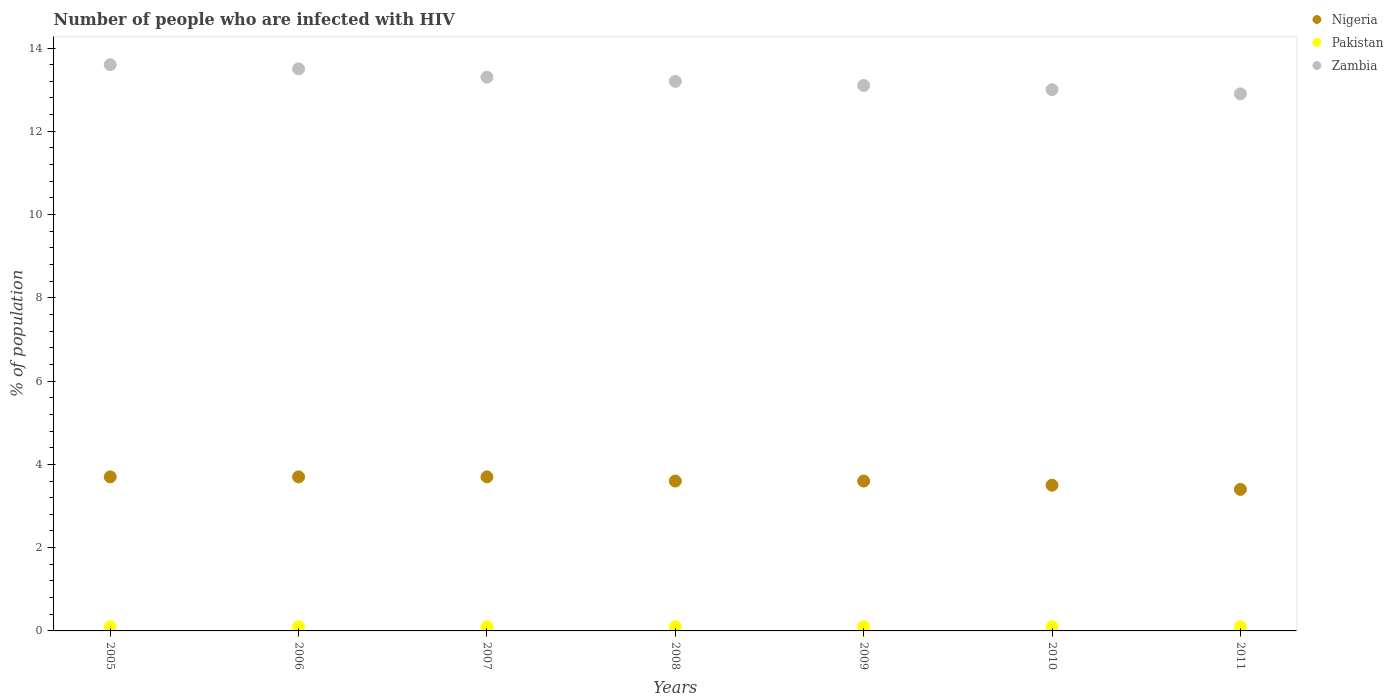Is the number of dotlines equal to the number of legend labels?
Ensure brevity in your answer.  Yes. In which year was the percentage of HIV infected population in in Pakistan maximum?
Provide a succinct answer. 2005. In which year was the percentage of HIV infected population in in Zambia minimum?
Offer a very short reply. 2011. What is the total percentage of HIV infected population in in Nigeria in the graph?
Offer a terse response. 25.2. What is the difference between the percentage of HIV infected population in in Zambia in 2009 and that in 2011?
Your response must be concise. 0.2. What is the difference between the percentage of HIV infected population in in Pakistan in 2006 and the percentage of HIV infected population in in Zambia in 2005?
Make the answer very short. -13.5. What is the average percentage of HIV infected population in in Zambia per year?
Your answer should be very brief. 13.23. In how many years, is the percentage of HIV infected population in in Nigeria greater than 8.8 %?
Your answer should be very brief. 0. What is the ratio of the percentage of HIV infected population in in Nigeria in 2006 to that in 2009?
Keep it short and to the point. 1.03. What is the difference between the highest and the lowest percentage of HIV infected population in in Zambia?
Your answer should be very brief. 0.7. Does the percentage of HIV infected population in in Zambia monotonically increase over the years?
Your answer should be compact. No. Is the percentage of HIV infected population in in Nigeria strictly greater than the percentage of HIV infected population in in Zambia over the years?
Ensure brevity in your answer.  No. Is the percentage of HIV infected population in in Zambia strictly less than the percentage of HIV infected population in in Nigeria over the years?
Offer a terse response. No. How many years are there in the graph?
Keep it short and to the point. 7. What is the difference between two consecutive major ticks on the Y-axis?
Your answer should be very brief. 2. Does the graph contain any zero values?
Provide a short and direct response. No. Does the graph contain grids?
Make the answer very short. No. Where does the legend appear in the graph?
Ensure brevity in your answer.  Top right. How are the legend labels stacked?
Keep it short and to the point. Vertical. What is the title of the graph?
Offer a very short reply. Number of people who are infected with HIV. Does "Cayman Islands" appear as one of the legend labels in the graph?
Provide a succinct answer. No. What is the label or title of the Y-axis?
Your answer should be very brief. % of population. What is the % of population of Zambia in 2005?
Make the answer very short. 13.6. What is the % of population in Nigeria in 2006?
Offer a very short reply. 3.7. What is the % of population in Pakistan in 2006?
Your answer should be compact. 0.1. What is the % of population of Nigeria in 2007?
Your answer should be compact. 3.7. What is the % of population in Pakistan in 2007?
Give a very brief answer. 0.1. What is the % of population of Zambia in 2007?
Your answer should be compact. 13.3. What is the % of population in Zambia in 2008?
Ensure brevity in your answer.  13.2. What is the % of population in Nigeria in 2009?
Provide a short and direct response. 3.6. What is the % of population in Pakistan in 2009?
Keep it short and to the point. 0.1. What is the % of population in Zambia in 2009?
Give a very brief answer. 13.1. What is the % of population of Pakistan in 2010?
Make the answer very short. 0.1. What is the % of population of Nigeria in 2011?
Make the answer very short. 3.4. What is the % of population of Pakistan in 2011?
Your answer should be compact. 0.1. What is the % of population of Zambia in 2011?
Provide a succinct answer. 12.9. Across all years, what is the maximum % of population of Nigeria?
Keep it short and to the point. 3.7. Across all years, what is the maximum % of population in Pakistan?
Give a very brief answer. 0.1. Across all years, what is the minimum % of population in Nigeria?
Your response must be concise. 3.4. What is the total % of population of Nigeria in the graph?
Ensure brevity in your answer.  25.2. What is the total % of population of Pakistan in the graph?
Ensure brevity in your answer.  0.7. What is the total % of population in Zambia in the graph?
Your answer should be very brief. 92.6. What is the difference between the % of population of Pakistan in 2005 and that in 2006?
Offer a very short reply. 0. What is the difference between the % of population of Zambia in 2005 and that in 2006?
Your answer should be compact. 0.1. What is the difference between the % of population in Zambia in 2005 and that in 2008?
Your answer should be compact. 0.4. What is the difference between the % of population of Nigeria in 2005 and that in 2009?
Offer a very short reply. 0.1. What is the difference between the % of population in Nigeria in 2005 and that in 2010?
Give a very brief answer. 0.2. What is the difference between the % of population in Pakistan in 2005 and that in 2010?
Give a very brief answer. 0. What is the difference between the % of population in Zambia in 2005 and that in 2010?
Your answer should be very brief. 0.6. What is the difference between the % of population in Nigeria in 2005 and that in 2011?
Your response must be concise. 0.3. What is the difference between the % of population in Zambia in 2005 and that in 2011?
Offer a very short reply. 0.7. What is the difference between the % of population in Pakistan in 2006 and that in 2007?
Offer a terse response. 0. What is the difference between the % of population of Zambia in 2006 and that in 2007?
Provide a succinct answer. 0.2. What is the difference between the % of population of Nigeria in 2006 and that in 2008?
Give a very brief answer. 0.1. What is the difference between the % of population in Zambia in 2006 and that in 2008?
Your answer should be compact. 0.3. What is the difference between the % of population of Nigeria in 2006 and that in 2009?
Make the answer very short. 0.1. What is the difference between the % of population of Zambia in 2006 and that in 2009?
Your answer should be very brief. 0.4. What is the difference between the % of population in Pakistan in 2006 and that in 2011?
Offer a terse response. 0. What is the difference between the % of population of Pakistan in 2007 and that in 2008?
Provide a short and direct response. 0. What is the difference between the % of population of Zambia in 2007 and that in 2008?
Keep it short and to the point. 0.1. What is the difference between the % of population of Nigeria in 2007 and that in 2009?
Ensure brevity in your answer.  0.1. What is the difference between the % of population in Nigeria in 2007 and that in 2010?
Your answer should be very brief. 0.2. What is the difference between the % of population of Zambia in 2007 and that in 2011?
Offer a terse response. 0.4. What is the difference between the % of population in Nigeria in 2008 and that in 2009?
Offer a terse response. 0. What is the difference between the % of population of Zambia in 2008 and that in 2009?
Your answer should be compact. 0.1. What is the difference between the % of population in Pakistan in 2008 and that in 2010?
Provide a short and direct response. 0. What is the difference between the % of population of Nigeria in 2009 and that in 2010?
Keep it short and to the point. 0.1. What is the difference between the % of population in Pakistan in 2009 and that in 2010?
Your answer should be compact. 0. What is the difference between the % of population of Nigeria in 2009 and that in 2011?
Give a very brief answer. 0.2. What is the difference between the % of population in Pakistan in 2009 and that in 2011?
Your response must be concise. 0. What is the difference between the % of population in Pakistan in 2010 and that in 2011?
Provide a succinct answer. 0. What is the difference between the % of population in Pakistan in 2005 and the % of population in Zambia in 2006?
Your answer should be compact. -13.4. What is the difference between the % of population in Nigeria in 2005 and the % of population in Pakistan in 2007?
Offer a very short reply. 3.6. What is the difference between the % of population of Nigeria in 2005 and the % of population of Zambia in 2007?
Your response must be concise. -9.6. What is the difference between the % of population of Nigeria in 2005 and the % of population of Zambia in 2008?
Offer a terse response. -9.5. What is the difference between the % of population in Nigeria in 2005 and the % of population in Pakistan in 2010?
Provide a succinct answer. 3.6. What is the difference between the % of population in Nigeria in 2005 and the % of population in Zambia in 2010?
Provide a succinct answer. -9.3. What is the difference between the % of population of Nigeria in 2006 and the % of population of Pakistan in 2007?
Your answer should be very brief. 3.6. What is the difference between the % of population of Nigeria in 2006 and the % of population of Zambia in 2007?
Keep it short and to the point. -9.6. What is the difference between the % of population of Nigeria in 2006 and the % of population of Pakistan in 2008?
Provide a succinct answer. 3.6. What is the difference between the % of population of Nigeria in 2006 and the % of population of Zambia in 2008?
Keep it short and to the point. -9.5. What is the difference between the % of population in Nigeria in 2006 and the % of population in Zambia in 2009?
Offer a terse response. -9.4. What is the difference between the % of population of Pakistan in 2006 and the % of population of Zambia in 2009?
Ensure brevity in your answer.  -13. What is the difference between the % of population of Nigeria in 2006 and the % of population of Pakistan in 2010?
Keep it short and to the point. 3.6. What is the difference between the % of population in Nigeria in 2006 and the % of population in Zambia in 2010?
Ensure brevity in your answer.  -9.3. What is the difference between the % of population in Pakistan in 2006 and the % of population in Zambia in 2010?
Make the answer very short. -12.9. What is the difference between the % of population in Pakistan in 2006 and the % of population in Zambia in 2011?
Your response must be concise. -12.8. What is the difference between the % of population in Nigeria in 2007 and the % of population in Pakistan in 2008?
Your answer should be compact. 3.6. What is the difference between the % of population of Pakistan in 2007 and the % of population of Zambia in 2008?
Provide a short and direct response. -13.1. What is the difference between the % of population of Nigeria in 2007 and the % of population of Pakistan in 2009?
Offer a very short reply. 3.6. What is the difference between the % of population in Nigeria in 2007 and the % of population in Zambia in 2009?
Ensure brevity in your answer.  -9.4. What is the difference between the % of population in Nigeria in 2007 and the % of population in Pakistan in 2010?
Your response must be concise. 3.6. What is the difference between the % of population of Pakistan in 2007 and the % of population of Zambia in 2011?
Offer a very short reply. -12.8. What is the difference between the % of population of Pakistan in 2008 and the % of population of Zambia in 2009?
Offer a terse response. -13. What is the difference between the % of population in Pakistan in 2008 and the % of population in Zambia in 2010?
Your response must be concise. -12.9. What is the difference between the % of population of Nigeria in 2009 and the % of population of Zambia in 2010?
Your answer should be very brief. -9.4. What is the difference between the % of population in Pakistan in 2009 and the % of population in Zambia in 2010?
Your answer should be compact. -12.9. What is the difference between the % of population of Nigeria in 2009 and the % of population of Pakistan in 2011?
Offer a terse response. 3.5. What is the difference between the % of population of Pakistan in 2009 and the % of population of Zambia in 2011?
Provide a short and direct response. -12.8. What is the average % of population of Nigeria per year?
Keep it short and to the point. 3.6. What is the average % of population in Pakistan per year?
Your answer should be very brief. 0.1. What is the average % of population of Zambia per year?
Ensure brevity in your answer.  13.23. In the year 2005, what is the difference between the % of population in Nigeria and % of population in Pakistan?
Provide a succinct answer. 3.6. In the year 2005, what is the difference between the % of population of Nigeria and % of population of Zambia?
Offer a very short reply. -9.9. In the year 2006, what is the difference between the % of population in Nigeria and % of population in Pakistan?
Keep it short and to the point. 3.6. In the year 2008, what is the difference between the % of population of Nigeria and % of population of Pakistan?
Your answer should be very brief. 3.5. In the year 2008, what is the difference between the % of population in Nigeria and % of population in Zambia?
Ensure brevity in your answer.  -9.6. In the year 2008, what is the difference between the % of population in Pakistan and % of population in Zambia?
Your response must be concise. -13.1. In the year 2010, what is the difference between the % of population of Nigeria and % of population of Pakistan?
Give a very brief answer. 3.4. In the year 2010, what is the difference between the % of population in Nigeria and % of population in Zambia?
Offer a very short reply. -9.5. In the year 2010, what is the difference between the % of population in Pakistan and % of population in Zambia?
Give a very brief answer. -12.9. In the year 2011, what is the difference between the % of population of Pakistan and % of population of Zambia?
Offer a terse response. -12.8. What is the ratio of the % of population in Nigeria in 2005 to that in 2006?
Make the answer very short. 1. What is the ratio of the % of population in Zambia in 2005 to that in 2006?
Give a very brief answer. 1.01. What is the ratio of the % of population of Nigeria in 2005 to that in 2007?
Your answer should be compact. 1. What is the ratio of the % of population of Zambia in 2005 to that in 2007?
Provide a short and direct response. 1.02. What is the ratio of the % of population of Nigeria in 2005 to that in 2008?
Your answer should be very brief. 1.03. What is the ratio of the % of population in Pakistan in 2005 to that in 2008?
Your answer should be very brief. 1. What is the ratio of the % of population of Zambia in 2005 to that in 2008?
Offer a very short reply. 1.03. What is the ratio of the % of population of Nigeria in 2005 to that in 2009?
Provide a succinct answer. 1.03. What is the ratio of the % of population of Zambia in 2005 to that in 2009?
Your answer should be compact. 1.04. What is the ratio of the % of population of Nigeria in 2005 to that in 2010?
Provide a short and direct response. 1.06. What is the ratio of the % of population in Zambia in 2005 to that in 2010?
Your response must be concise. 1.05. What is the ratio of the % of population in Nigeria in 2005 to that in 2011?
Make the answer very short. 1.09. What is the ratio of the % of population in Zambia in 2005 to that in 2011?
Provide a succinct answer. 1.05. What is the ratio of the % of population in Pakistan in 2006 to that in 2007?
Your answer should be very brief. 1. What is the ratio of the % of population in Nigeria in 2006 to that in 2008?
Provide a short and direct response. 1.03. What is the ratio of the % of population of Zambia in 2006 to that in 2008?
Ensure brevity in your answer.  1.02. What is the ratio of the % of population in Nigeria in 2006 to that in 2009?
Ensure brevity in your answer.  1.03. What is the ratio of the % of population of Zambia in 2006 to that in 2009?
Ensure brevity in your answer.  1.03. What is the ratio of the % of population in Nigeria in 2006 to that in 2010?
Your answer should be very brief. 1.06. What is the ratio of the % of population in Nigeria in 2006 to that in 2011?
Ensure brevity in your answer.  1.09. What is the ratio of the % of population of Zambia in 2006 to that in 2011?
Your answer should be very brief. 1.05. What is the ratio of the % of population of Nigeria in 2007 to that in 2008?
Give a very brief answer. 1.03. What is the ratio of the % of population in Pakistan in 2007 to that in 2008?
Make the answer very short. 1. What is the ratio of the % of population in Zambia in 2007 to that in 2008?
Ensure brevity in your answer.  1.01. What is the ratio of the % of population of Nigeria in 2007 to that in 2009?
Your response must be concise. 1.03. What is the ratio of the % of population of Zambia in 2007 to that in 2009?
Make the answer very short. 1.02. What is the ratio of the % of population in Nigeria in 2007 to that in 2010?
Your answer should be very brief. 1.06. What is the ratio of the % of population of Zambia in 2007 to that in 2010?
Make the answer very short. 1.02. What is the ratio of the % of population of Nigeria in 2007 to that in 2011?
Offer a terse response. 1.09. What is the ratio of the % of population of Zambia in 2007 to that in 2011?
Your answer should be very brief. 1.03. What is the ratio of the % of population of Pakistan in 2008 to that in 2009?
Give a very brief answer. 1. What is the ratio of the % of population in Zambia in 2008 to that in 2009?
Ensure brevity in your answer.  1.01. What is the ratio of the % of population of Nigeria in 2008 to that in 2010?
Your response must be concise. 1.03. What is the ratio of the % of population of Zambia in 2008 to that in 2010?
Your response must be concise. 1.02. What is the ratio of the % of population of Nigeria in 2008 to that in 2011?
Provide a succinct answer. 1.06. What is the ratio of the % of population of Pakistan in 2008 to that in 2011?
Your response must be concise. 1. What is the ratio of the % of population in Zambia in 2008 to that in 2011?
Your response must be concise. 1.02. What is the ratio of the % of population of Nigeria in 2009 to that in 2010?
Ensure brevity in your answer.  1.03. What is the ratio of the % of population of Pakistan in 2009 to that in 2010?
Keep it short and to the point. 1. What is the ratio of the % of population in Zambia in 2009 to that in 2010?
Make the answer very short. 1.01. What is the ratio of the % of population of Nigeria in 2009 to that in 2011?
Offer a terse response. 1.06. What is the ratio of the % of population of Pakistan in 2009 to that in 2011?
Your answer should be very brief. 1. What is the ratio of the % of population in Zambia in 2009 to that in 2011?
Your response must be concise. 1.02. What is the ratio of the % of population in Nigeria in 2010 to that in 2011?
Your answer should be very brief. 1.03. What is the ratio of the % of population in Pakistan in 2010 to that in 2011?
Offer a terse response. 1. What is the difference between the highest and the second highest % of population of Pakistan?
Keep it short and to the point. 0. What is the difference between the highest and the second highest % of population in Zambia?
Offer a terse response. 0.1. What is the difference between the highest and the lowest % of population of Pakistan?
Your answer should be very brief. 0. What is the difference between the highest and the lowest % of population in Zambia?
Keep it short and to the point. 0.7. 